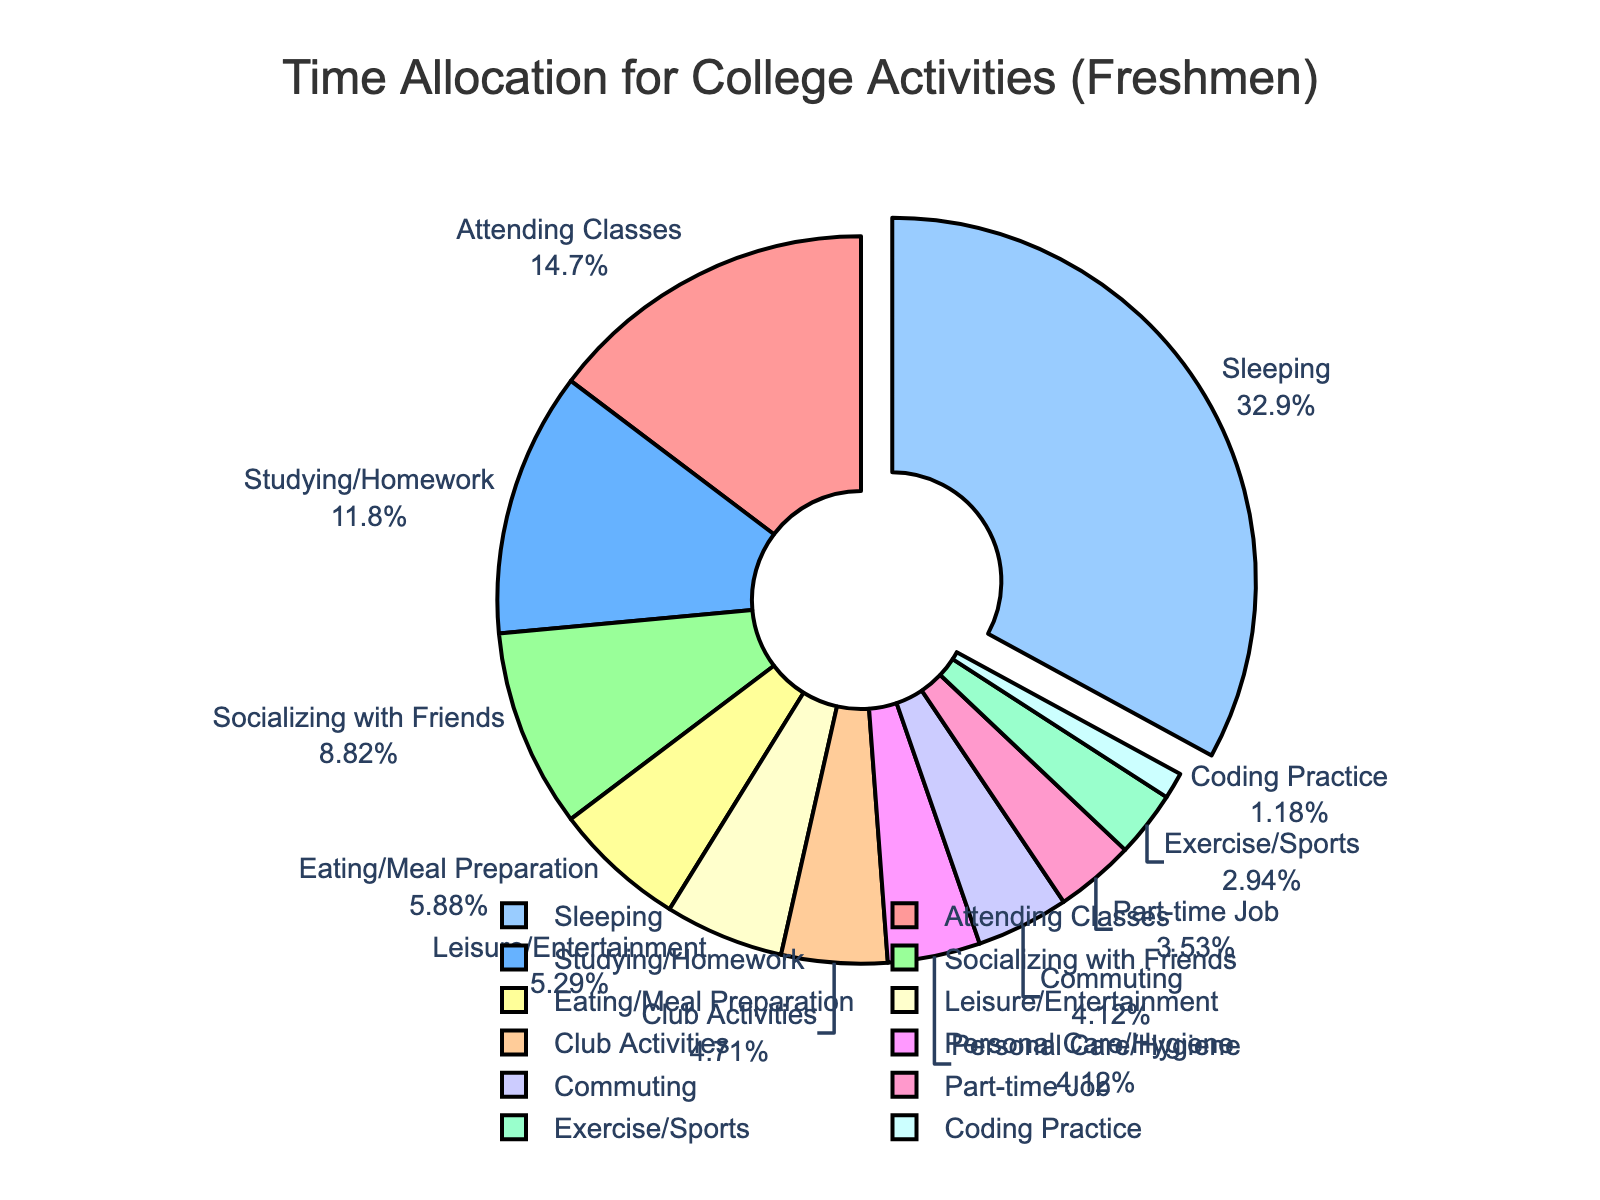Which activity takes up the largest portion of time? The biggest section of the pie chart represents the activity with the most hours. In this case, it is "Sleeping" which is visually pulled out as well.
Answer: Sleeping How much more time is spent on studying/homework compared to coding practice? Subtract the hours for coding practice (2) from the hours for studying/homework (20): 20 - 2 = 18
Answer: 18 What percentage of time is allocated to socializing with friends? Look at the pie chart's label for "Socializing with Friends" to find the percentage. The chart shows the percentage alongside the activity names.
Answer: 11.5% Which activity has the smallest portion of time, and what is its percentage? The smallest portion can be visually identified by finding the thinnest slice in the pie chart, which is "Coding Practice." Check its label for the percentage.
Answer: Coding Practice, 1.1% How many hours are spent on personal care/hygiene and commuting combined? Add the hours for Personal Care/Hygiene (7) and Commuting (7): 7 + 7 = 14
Answer: 14 Is more time spent on club activities or part-time jobs, and by how many hours? Compare the hours for club activities (8) and part-time jobs (6). Subtract the smaller number from the larger one: 8 - 6 = 2
Answer: Club Activities, 2 What is the total percentage of time spent on eating/meal preparation and leisure/entertainment? Add the percentages for Eating/Meal Preparation and Leisure/Entertainment by referring to their labels on the pie chart. 5.7% (Eating/Meal Preparation) + 5.2% (Leisure/Entertainment) = 10.9%
Answer: 10.9% How does the time spent exercising/sports compare with coding practice? Look at the hours for Exercise/Sports (5) and Coding Practice (2), then compare them. 5 is greater than 2.
Answer: More time on Exercise/Sports Which activities together make up over 50% of the time? Identify and add up the largest slices until the sum exceeds 50%. Sleeping (32.2%) + Attending Classes (14.3%) + Studying/Homework (11.5%) = 58%.
Answer: Sleeping, Attending Classes, Studying/Homework What's the difference in the total hours between socializing with friends and attending classes? Subtract the hours for Socializing with Friends (15) from Attending Classes (25): 25 - 15 = 10
Answer: 10 